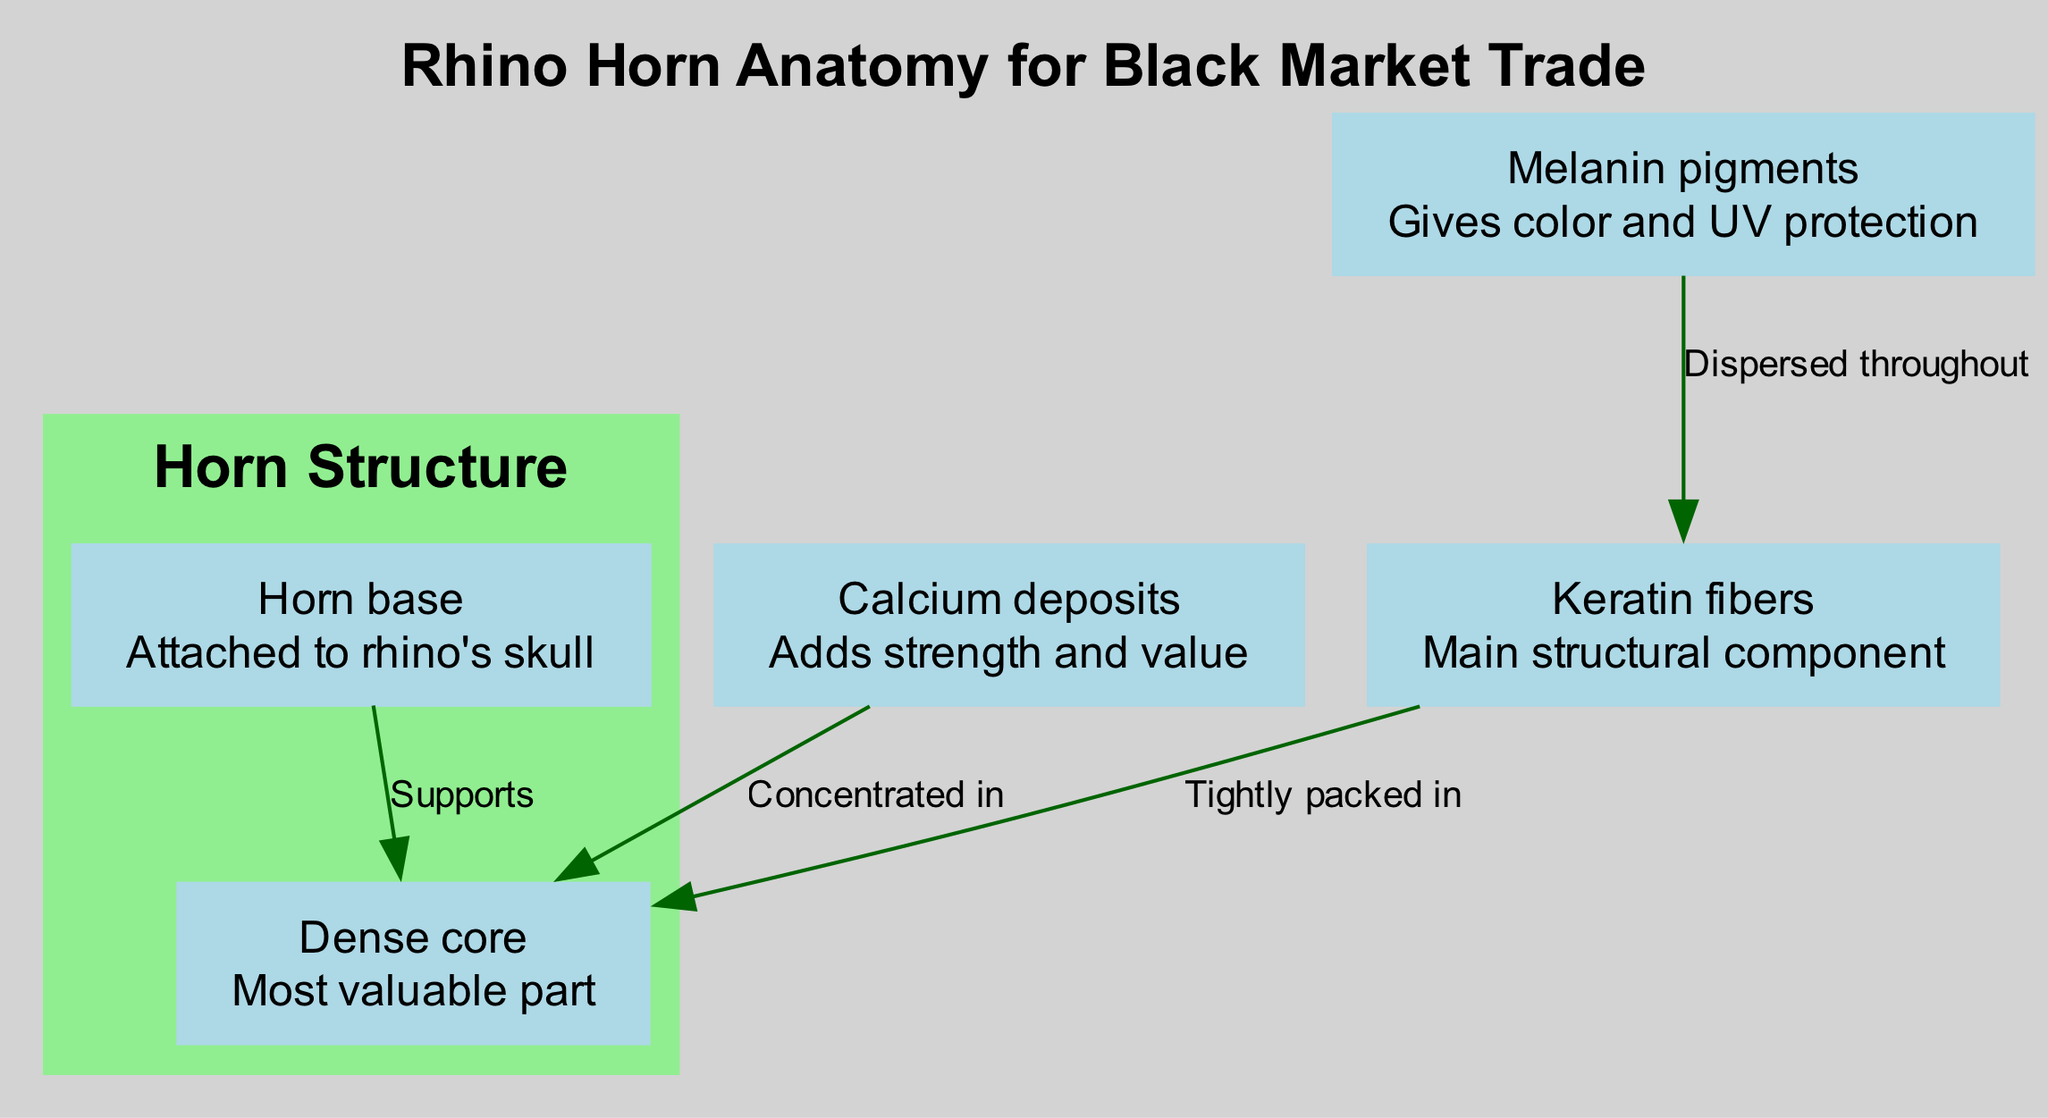What is the main structural component of the rhino horn? The diagram directly labels the "Keratin fibers" as the main structural component of the rhino horn. This can be seen in the node description.
Answer: Keratin fibers How many nodes are present in the diagram? The diagram includes five distinct nodes: Keratin fibers, Melanin pigments, Calcium deposits, Dense core, and Horn base. Counting these gives a total of five nodes.
Answer: 5 What gives color and UV protection to the horn? The node labeled "Melanin pigments" specifically states that it gives color and UV protection, as indicated in its description within the diagram.
Answer: Melanin pigments Which component is the most valuable part of the horn? The "Dense core" node is highlighted in the diagram as the most valuable part, according to its description, signifying its importance in the context of rhino horn composition.
Answer: Dense core What supports the core of the horn? The "Horn base" node has a directed edge to the "core," with the label stating "Supports." This indicates that the base provides structural support for the core of the horn.
Answer: Horn base Which components are concentrated in the core? The diagram shows that both "Calcium deposits" and "Keratin fibers" are directly connected to the "core," with the connections indicating that they are concentrated in this structure.
Answer: Calcium deposits, Keratin fibers How are melanin pigments distributed throughout the horn? The diagram clarifies that melanin pigments are "Dispersed throughout" the keratin, which shows that they do not cluster but spread evenly within the horn's structure.
Answer: Dispersed throughout What is the relationship between keratin fibers and the core? The edge between "keratin" and "core" is labeled "Tightly packed in," which indicates a strong structural relationship, with keratin fibers being densely arranged within the core of the horn.
Answer: Tightly packed in Which component adds strength and value to the horn? The "Calcium deposits" node describes its role in adding strength and value to the horn, indicating its critical function in contributing to the horn's robustness.
Answer: Calcium deposits 